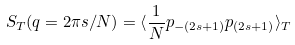<formula> <loc_0><loc_0><loc_500><loc_500>S _ { T } ( q = 2 \pi s / N ) = \langle \frac { 1 } { N } p _ { - ( 2 s + 1 ) } p _ { ( 2 s + 1 ) } \rangle _ { T }</formula> 